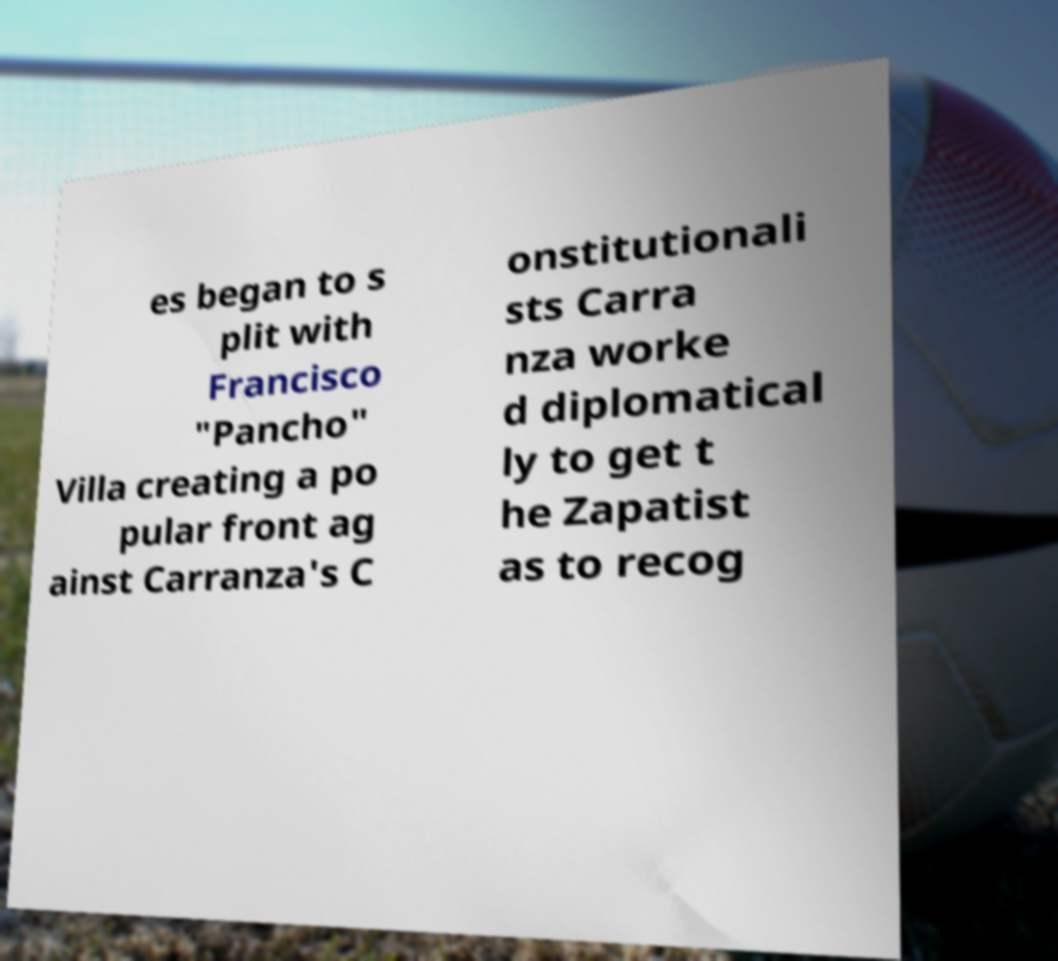What messages or text are displayed in this image? I need them in a readable, typed format. es began to s plit with Francisco "Pancho" Villa creating a po pular front ag ainst Carranza's C onstitutionali sts Carra nza worke d diplomatical ly to get t he Zapatist as to recog 